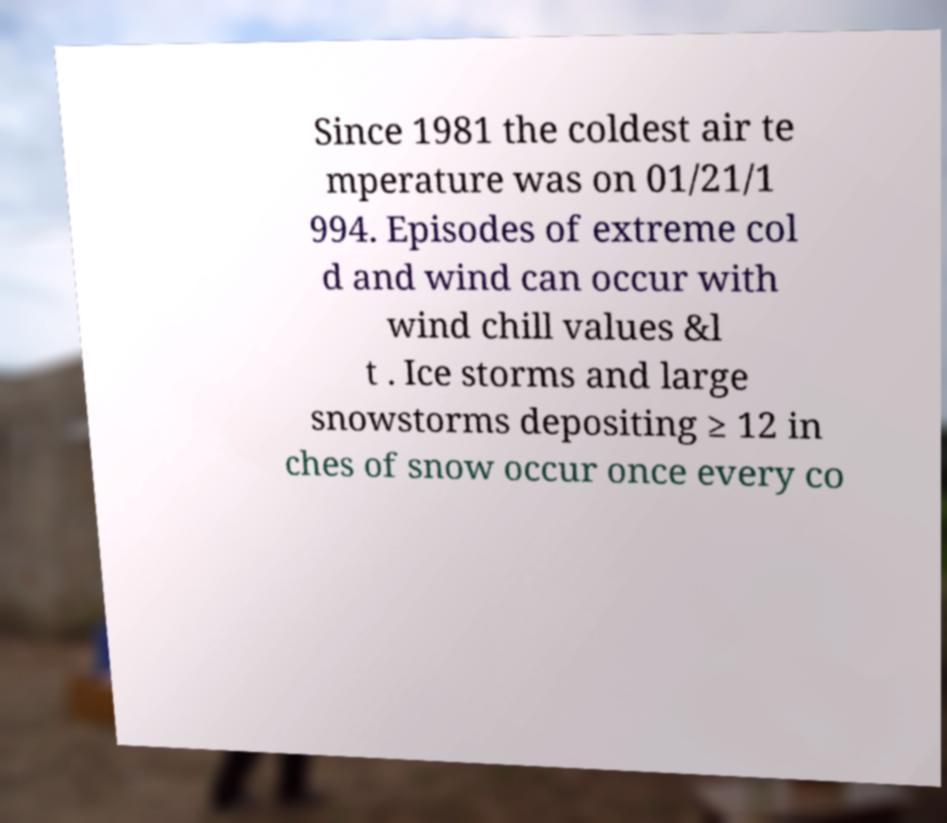Please read and relay the text visible in this image. What does it say? Since 1981 the coldest air te mperature was on 01/21/1 994. Episodes of extreme col d and wind can occur with wind chill values &l t . Ice storms and large snowstorms depositing ≥ 12 in ches of snow occur once every co 